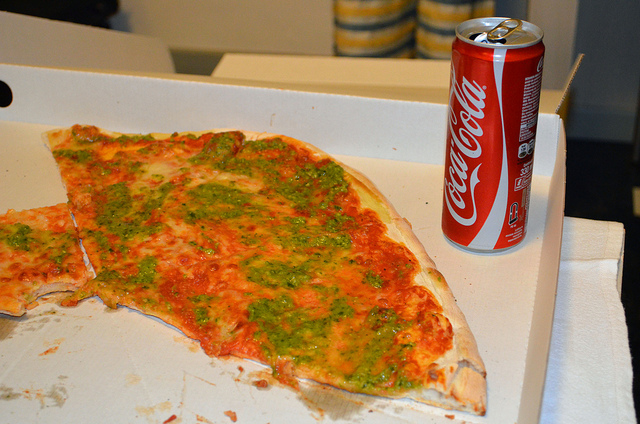<image>What is green on this pizza? I am not sure what is green on the pizza. It could be pesto, onion, broccoli, basil, or spinach. What is green on this pizza? I am not sure what is green on this pizza. It can be seen 'pesto', 'onion', 'broccoli', 'basil', or 'spinach'. 